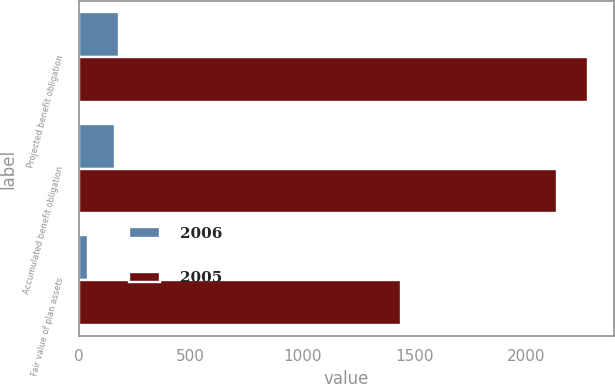Convert chart to OTSL. <chart><loc_0><loc_0><loc_500><loc_500><stacked_bar_chart><ecel><fcel>Projected benefit obligation<fcel>Accumulated benefit obligation<fcel>Fair value of plan assets<nl><fcel>2006<fcel>180.6<fcel>163.6<fcel>43.2<nl><fcel>2005<fcel>2279.5<fcel>2138.4<fcel>1442.3<nl></chart> 